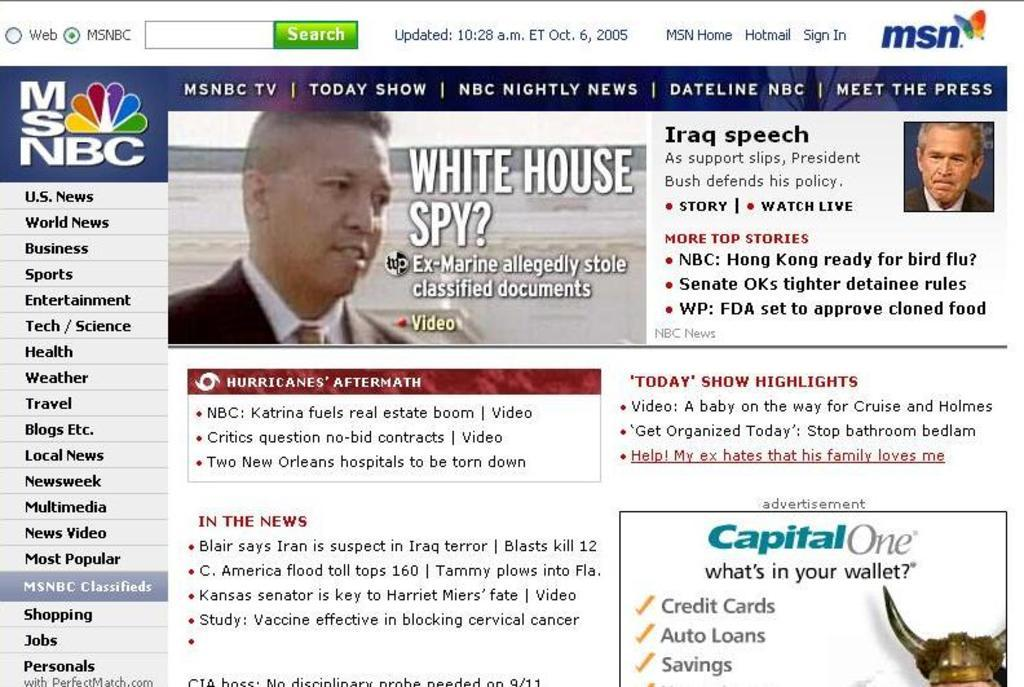What type of content is displayed in the image? The image is a web page. What can be found on the web page besides images? There is text on the web page. How many people are depicted in the images on the web page? There are two images of two different persons on the web page. How does the fog affect the visibility of the images on the web page? There is no fog present in the image, as it is a web page and not an outdoor scene. 